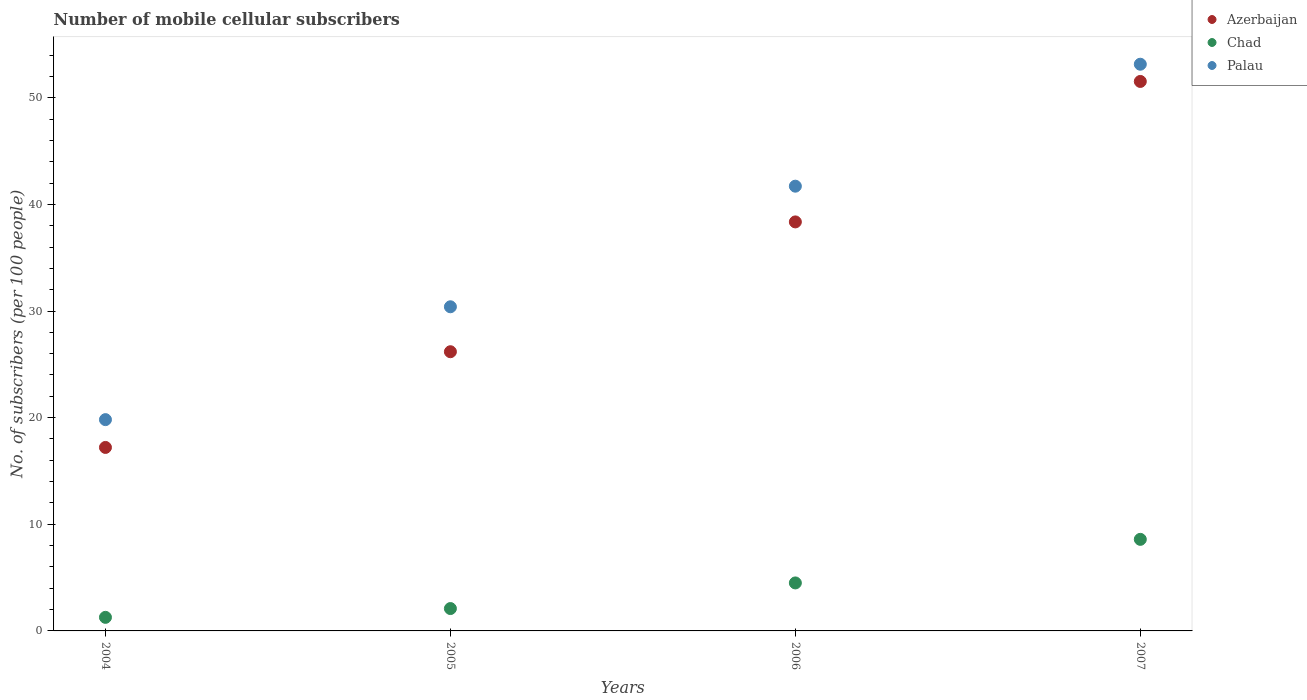Is the number of dotlines equal to the number of legend labels?
Keep it short and to the point. Yes. What is the number of mobile cellular subscribers in Palau in 2004?
Offer a terse response. 19.81. Across all years, what is the maximum number of mobile cellular subscribers in Azerbaijan?
Your response must be concise. 51.53. Across all years, what is the minimum number of mobile cellular subscribers in Palau?
Keep it short and to the point. 19.81. In which year was the number of mobile cellular subscribers in Azerbaijan maximum?
Your response must be concise. 2007. What is the total number of mobile cellular subscribers in Palau in the graph?
Make the answer very short. 145.06. What is the difference between the number of mobile cellular subscribers in Azerbaijan in 2006 and that in 2007?
Your answer should be compact. -13.17. What is the difference between the number of mobile cellular subscribers in Palau in 2006 and the number of mobile cellular subscribers in Chad in 2005?
Offer a very short reply. 39.61. What is the average number of mobile cellular subscribers in Azerbaijan per year?
Provide a short and direct response. 33.32. In the year 2006, what is the difference between the number of mobile cellular subscribers in Palau and number of mobile cellular subscribers in Azerbaijan?
Provide a succinct answer. 3.35. What is the ratio of the number of mobile cellular subscribers in Chad in 2004 to that in 2005?
Give a very brief answer. 0.61. What is the difference between the highest and the second highest number of mobile cellular subscribers in Palau?
Offer a very short reply. 11.44. What is the difference between the highest and the lowest number of mobile cellular subscribers in Azerbaijan?
Keep it short and to the point. 34.32. In how many years, is the number of mobile cellular subscribers in Chad greater than the average number of mobile cellular subscribers in Chad taken over all years?
Give a very brief answer. 2. Is the sum of the number of mobile cellular subscribers in Chad in 2004 and 2006 greater than the maximum number of mobile cellular subscribers in Azerbaijan across all years?
Make the answer very short. No. Is the number of mobile cellular subscribers in Chad strictly less than the number of mobile cellular subscribers in Azerbaijan over the years?
Make the answer very short. Yes. How many years are there in the graph?
Your answer should be very brief. 4. What is the difference between two consecutive major ticks on the Y-axis?
Provide a short and direct response. 10. Does the graph contain any zero values?
Your answer should be very brief. No. Does the graph contain grids?
Offer a terse response. No. How many legend labels are there?
Your answer should be compact. 3. How are the legend labels stacked?
Offer a terse response. Vertical. What is the title of the graph?
Your answer should be very brief. Number of mobile cellular subscribers. What is the label or title of the Y-axis?
Provide a short and direct response. No. of subscribers (per 100 people). What is the No. of subscribers (per 100 people) of Azerbaijan in 2004?
Your answer should be very brief. 17.21. What is the No. of subscribers (per 100 people) in Chad in 2004?
Keep it short and to the point. 1.27. What is the No. of subscribers (per 100 people) in Palau in 2004?
Provide a succinct answer. 19.81. What is the No. of subscribers (per 100 people) of Azerbaijan in 2005?
Your answer should be compact. 26.18. What is the No. of subscribers (per 100 people) of Chad in 2005?
Provide a succinct answer. 2.1. What is the No. of subscribers (per 100 people) in Palau in 2005?
Offer a terse response. 30.4. What is the No. of subscribers (per 100 people) of Azerbaijan in 2006?
Give a very brief answer. 38.36. What is the No. of subscribers (per 100 people) of Chad in 2006?
Offer a terse response. 4.5. What is the No. of subscribers (per 100 people) in Palau in 2006?
Keep it short and to the point. 41.7. What is the No. of subscribers (per 100 people) of Azerbaijan in 2007?
Provide a short and direct response. 51.53. What is the No. of subscribers (per 100 people) in Chad in 2007?
Provide a short and direct response. 8.59. What is the No. of subscribers (per 100 people) of Palau in 2007?
Give a very brief answer. 53.14. Across all years, what is the maximum No. of subscribers (per 100 people) in Azerbaijan?
Your response must be concise. 51.53. Across all years, what is the maximum No. of subscribers (per 100 people) of Chad?
Your answer should be compact. 8.59. Across all years, what is the maximum No. of subscribers (per 100 people) in Palau?
Ensure brevity in your answer.  53.14. Across all years, what is the minimum No. of subscribers (per 100 people) in Azerbaijan?
Keep it short and to the point. 17.21. Across all years, what is the minimum No. of subscribers (per 100 people) of Chad?
Provide a succinct answer. 1.27. Across all years, what is the minimum No. of subscribers (per 100 people) of Palau?
Ensure brevity in your answer.  19.81. What is the total No. of subscribers (per 100 people) in Azerbaijan in the graph?
Keep it short and to the point. 133.27. What is the total No. of subscribers (per 100 people) of Chad in the graph?
Keep it short and to the point. 16.46. What is the total No. of subscribers (per 100 people) in Palau in the graph?
Offer a terse response. 145.06. What is the difference between the No. of subscribers (per 100 people) in Azerbaijan in 2004 and that in 2005?
Keep it short and to the point. -8.97. What is the difference between the No. of subscribers (per 100 people) of Chad in 2004 and that in 2005?
Provide a succinct answer. -0.82. What is the difference between the No. of subscribers (per 100 people) in Palau in 2004 and that in 2005?
Make the answer very short. -10.58. What is the difference between the No. of subscribers (per 100 people) in Azerbaijan in 2004 and that in 2006?
Keep it short and to the point. -21.15. What is the difference between the No. of subscribers (per 100 people) of Chad in 2004 and that in 2006?
Your response must be concise. -3.23. What is the difference between the No. of subscribers (per 100 people) in Palau in 2004 and that in 2006?
Make the answer very short. -21.89. What is the difference between the No. of subscribers (per 100 people) of Azerbaijan in 2004 and that in 2007?
Keep it short and to the point. -34.32. What is the difference between the No. of subscribers (per 100 people) in Chad in 2004 and that in 2007?
Give a very brief answer. -7.31. What is the difference between the No. of subscribers (per 100 people) of Palau in 2004 and that in 2007?
Your response must be concise. -33.33. What is the difference between the No. of subscribers (per 100 people) of Azerbaijan in 2005 and that in 2006?
Your answer should be very brief. -12.17. What is the difference between the No. of subscribers (per 100 people) in Chad in 2005 and that in 2006?
Provide a short and direct response. -2.4. What is the difference between the No. of subscribers (per 100 people) in Palau in 2005 and that in 2006?
Provide a succinct answer. -11.31. What is the difference between the No. of subscribers (per 100 people) in Azerbaijan in 2005 and that in 2007?
Ensure brevity in your answer.  -25.35. What is the difference between the No. of subscribers (per 100 people) of Chad in 2005 and that in 2007?
Your answer should be very brief. -6.49. What is the difference between the No. of subscribers (per 100 people) of Palau in 2005 and that in 2007?
Provide a succinct answer. -22.75. What is the difference between the No. of subscribers (per 100 people) of Azerbaijan in 2006 and that in 2007?
Your answer should be very brief. -13.17. What is the difference between the No. of subscribers (per 100 people) of Chad in 2006 and that in 2007?
Ensure brevity in your answer.  -4.09. What is the difference between the No. of subscribers (per 100 people) in Palau in 2006 and that in 2007?
Your response must be concise. -11.44. What is the difference between the No. of subscribers (per 100 people) in Azerbaijan in 2004 and the No. of subscribers (per 100 people) in Chad in 2005?
Offer a terse response. 15.11. What is the difference between the No. of subscribers (per 100 people) in Azerbaijan in 2004 and the No. of subscribers (per 100 people) in Palau in 2005?
Offer a terse response. -13.19. What is the difference between the No. of subscribers (per 100 people) of Chad in 2004 and the No. of subscribers (per 100 people) of Palau in 2005?
Keep it short and to the point. -29.12. What is the difference between the No. of subscribers (per 100 people) in Azerbaijan in 2004 and the No. of subscribers (per 100 people) in Chad in 2006?
Keep it short and to the point. 12.71. What is the difference between the No. of subscribers (per 100 people) of Azerbaijan in 2004 and the No. of subscribers (per 100 people) of Palau in 2006?
Your response must be concise. -24.5. What is the difference between the No. of subscribers (per 100 people) of Chad in 2004 and the No. of subscribers (per 100 people) of Palau in 2006?
Offer a terse response. -40.43. What is the difference between the No. of subscribers (per 100 people) of Azerbaijan in 2004 and the No. of subscribers (per 100 people) of Chad in 2007?
Your answer should be compact. 8.62. What is the difference between the No. of subscribers (per 100 people) of Azerbaijan in 2004 and the No. of subscribers (per 100 people) of Palau in 2007?
Make the answer very short. -35.94. What is the difference between the No. of subscribers (per 100 people) of Chad in 2004 and the No. of subscribers (per 100 people) of Palau in 2007?
Make the answer very short. -51.87. What is the difference between the No. of subscribers (per 100 people) in Azerbaijan in 2005 and the No. of subscribers (per 100 people) in Chad in 2006?
Provide a succinct answer. 21.68. What is the difference between the No. of subscribers (per 100 people) of Azerbaijan in 2005 and the No. of subscribers (per 100 people) of Palau in 2006?
Provide a short and direct response. -15.52. What is the difference between the No. of subscribers (per 100 people) of Chad in 2005 and the No. of subscribers (per 100 people) of Palau in 2006?
Keep it short and to the point. -39.61. What is the difference between the No. of subscribers (per 100 people) of Azerbaijan in 2005 and the No. of subscribers (per 100 people) of Chad in 2007?
Your response must be concise. 17.59. What is the difference between the No. of subscribers (per 100 people) of Azerbaijan in 2005 and the No. of subscribers (per 100 people) of Palau in 2007?
Provide a short and direct response. -26.96. What is the difference between the No. of subscribers (per 100 people) of Chad in 2005 and the No. of subscribers (per 100 people) of Palau in 2007?
Your answer should be compact. -51.04. What is the difference between the No. of subscribers (per 100 people) in Azerbaijan in 2006 and the No. of subscribers (per 100 people) in Chad in 2007?
Your response must be concise. 29.77. What is the difference between the No. of subscribers (per 100 people) in Azerbaijan in 2006 and the No. of subscribers (per 100 people) in Palau in 2007?
Provide a short and direct response. -14.79. What is the difference between the No. of subscribers (per 100 people) in Chad in 2006 and the No. of subscribers (per 100 people) in Palau in 2007?
Offer a terse response. -48.64. What is the average No. of subscribers (per 100 people) in Azerbaijan per year?
Offer a very short reply. 33.32. What is the average No. of subscribers (per 100 people) of Chad per year?
Your response must be concise. 4.11. What is the average No. of subscribers (per 100 people) in Palau per year?
Keep it short and to the point. 36.26. In the year 2004, what is the difference between the No. of subscribers (per 100 people) in Azerbaijan and No. of subscribers (per 100 people) in Chad?
Ensure brevity in your answer.  15.93. In the year 2004, what is the difference between the No. of subscribers (per 100 people) of Azerbaijan and No. of subscribers (per 100 people) of Palau?
Your answer should be compact. -2.61. In the year 2004, what is the difference between the No. of subscribers (per 100 people) of Chad and No. of subscribers (per 100 people) of Palau?
Keep it short and to the point. -18.54. In the year 2005, what is the difference between the No. of subscribers (per 100 people) of Azerbaijan and No. of subscribers (per 100 people) of Chad?
Offer a very short reply. 24.08. In the year 2005, what is the difference between the No. of subscribers (per 100 people) of Azerbaijan and No. of subscribers (per 100 people) of Palau?
Your answer should be compact. -4.22. In the year 2005, what is the difference between the No. of subscribers (per 100 people) of Chad and No. of subscribers (per 100 people) of Palau?
Offer a terse response. -28.3. In the year 2006, what is the difference between the No. of subscribers (per 100 people) in Azerbaijan and No. of subscribers (per 100 people) in Chad?
Your answer should be compact. 33.86. In the year 2006, what is the difference between the No. of subscribers (per 100 people) in Azerbaijan and No. of subscribers (per 100 people) in Palau?
Provide a short and direct response. -3.35. In the year 2006, what is the difference between the No. of subscribers (per 100 people) in Chad and No. of subscribers (per 100 people) in Palau?
Offer a very short reply. -37.2. In the year 2007, what is the difference between the No. of subscribers (per 100 people) of Azerbaijan and No. of subscribers (per 100 people) of Chad?
Offer a very short reply. 42.94. In the year 2007, what is the difference between the No. of subscribers (per 100 people) in Azerbaijan and No. of subscribers (per 100 people) in Palau?
Provide a succinct answer. -1.61. In the year 2007, what is the difference between the No. of subscribers (per 100 people) of Chad and No. of subscribers (per 100 people) of Palau?
Offer a very short reply. -44.55. What is the ratio of the No. of subscribers (per 100 people) in Azerbaijan in 2004 to that in 2005?
Provide a succinct answer. 0.66. What is the ratio of the No. of subscribers (per 100 people) of Chad in 2004 to that in 2005?
Offer a terse response. 0.61. What is the ratio of the No. of subscribers (per 100 people) of Palau in 2004 to that in 2005?
Your answer should be very brief. 0.65. What is the ratio of the No. of subscribers (per 100 people) in Azerbaijan in 2004 to that in 2006?
Your answer should be compact. 0.45. What is the ratio of the No. of subscribers (per 100 people) in Chad in 2004 to that in 2006?
Your answer should be compact. 0.28. What is the ratio of the No. of subscribers (per 100 people) of Palau in 2004 to that in 2006?
Make the answer very short. 0.48. What is the ratio of the No. of subscribers (per 100 people) of Azerbaijan in 2004 to that in 2007?
Your answer should be very brief. 0.33. What is the ratio of the No. of subscribers (per 100 people) of Chad in 2004 to that in 2007?
Your answer should be very brief. 0.15. What is the ratio of the No. of subscribers (per 100 people) of Palau in 2004 to that in 2007?
Offer a terse response. 0.37. What is the ratio of the No. of subscribers (per 100 people) of Azerbaijan in 2005 to that in 2006?
Keep it short and to the point. 0.68. What is the ratio of the No. of subscribers (per 100 people) of Chad in 2005 to that in 2006?
Provide a short and direct response. 0.47. What is the ratio of the No. of subscribers (per 100 people) in Palau in 2005 to that in 2006?
Ensure brevity in your answer.  0.73. What is the ratio of the No. of subscribers (per 100 people) of Azerbaijan in 2005 to that in 2007?
Make the answer very short. 0.51. What is the ratio of the No. of subscribers (per 100 people) of Chad in 2005 to that in 2007?
Offer a very short reply. 0.24. What is the ratio of the No. of subscribers (per 100 people) in Palau in 2005 to that in 2007?
Provide a succinct answer. 0.57. What is the ratio of the No. of subscribers (per 100 people) in Azerbaijan in 2006 to that in 2007?
Provide a succinct answer. 0.74. What is the ratio of the No. of subscribers (per 100 people) in Chad in 2006 to that in 2007?
Ensure brevity in your answer.  0.52. What is the ratio of the No. of subscribers (per 100 people) in Palau in 2006 to that in 2007?
Provide a succinct answer. 0.78. What is the difference between the highest and the second highest No. of subscribers (per 100 people) in Azerbaijan?
Ensure brevity in your answer.  13.17. What is the difference between the highest and the second highest No. of subscribers (per 100 people) of Chad?
Your answer should be compact. 4.09. What is the difference between the highest and the second highest No. of subscribers (per 100 people) in Palau?
Provide a short and direct response. 11.44. What is the difference between the highest and the lowest No. of subscribers (per 100 people) in Azerbaijan?
Provide a succinct answer. 34.32. What is the difference between the highest and the lowest No. of subscribers (per 100 people) in Chad?
Keep it short and to the point. 7.31. What is the difference between the highest and the lowest No. of subscribers (per 100 people) of Palau?
Make the answer very short. 33.33. 